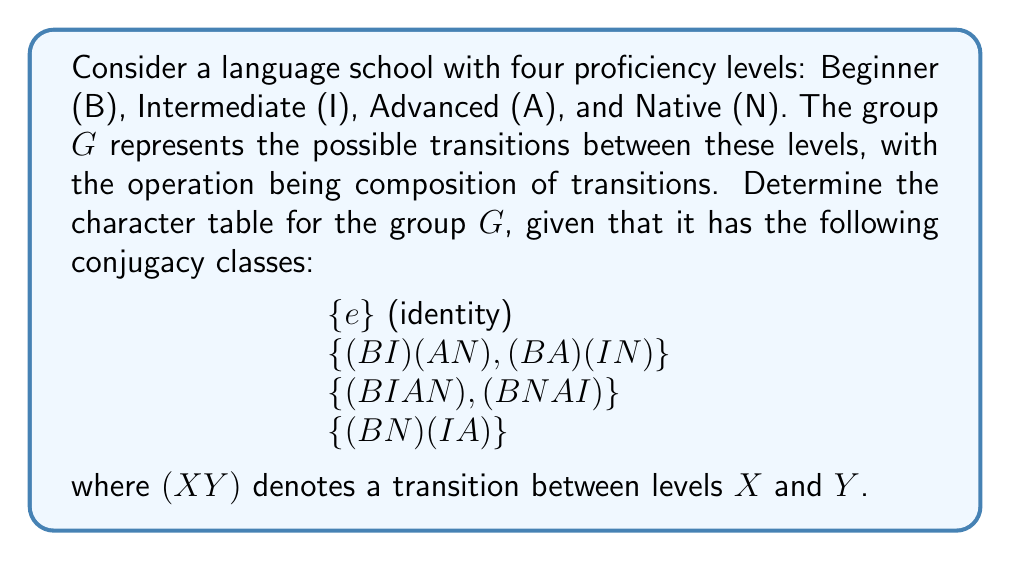Help me with this question. Let's approach this step-by-step:

1) First, we need to identify the order of the group. There are 5 elements in total, so $|G| = 5$.

2) The number of irreducible representations is equal to the number of conjugacy classes. We have 4 conjugacy classes, so there will be 4 irreducible representations.

3) The sum of the squares of the dimensions of the irreducible representations must equal the order of the group. The only way to do this with 4 representations is $1^2 + 1^2 + 1^2 + 1^2 = 4$.

4) This means all irreducible representations are 1-dimensional, and the character table will be 4x4.

5) The first row of the character table always consists of 1's (the trivial representation).

6) The first column always consists of the dimensions of the representations, which are all 1 in this case.

7) For the remaining entries, we need to find 3 more linear characters. Since $G$ is abelian (all conjugacy classes have size 1), these characters are just the homomorphisms from $G$ to $\mathbb{C}^*$.

8) Let $\omega = e^{2\pi i/3}$ be a primitive third root of unity. We can define our characters as follows:

   $\chi_1(g) = 1$ for all $g \in G$ (trivial character)
   $\chi_2(e) = 1, \chi_2((B I)(A N)) = \omega, \chi_2((B I A N)) = \omega^2, \chi_2((B N)(I A)) = 1$
   $\chi_3(e) = 1, \chi_3((B I)(A N)) = \omega^2, \chi_3((B I A N)) = \omega, \chi_3((B N)(I A)) = 1$
   $\chi_4(e) = 1, \chi_4((B I)(A N)) = 1, \chi_4((B I A N)) = 1, \chi_4((B N)(I A)) = -1$

9) Now we can construct the character table:

   $$\begin{array}{c|cccc}
    G & \{e\} & \{(B I)(A N), (B A)(I N)\} & \{(B I A N), (B N A I)\} & \{(B N)(I A)\} \\
    \hline
    \chi_1 & 1 & 1 & 1 & 1 \\
    \chi_2 & 1 & \omega & \omega^2 & 1 \\
    \chi_3 & 1 & \omega^2 & \omega & 1 \\
    \chi_4 & 1 & 1 & 1 & -1
   \end{array}$$

   where $\omega = e^{2\pi i/3} = -\frac{1}{2} + i\frac{\sqrt{3}}{2}$.
Answer: $$\begin{array}{c|cccc}
G & \{e\} & \{(B I)(A N), (B A)(I N)\} & \{(B I A N), (B N A I)\} & \{(B N)(I A)\} \\
\hline
\chi_1 & 1 & 1 & 1 & 1 \\
\chi_2 & 1 & \omega & \omega^2 & 1 \\
\chi_3 & 1 & \omega^2 & \omega & 1 \\
\chi_4 & 1 & 1 & 1 & -1
\end{array}$$
where $\omega = e^{2\pi i/3}$ 